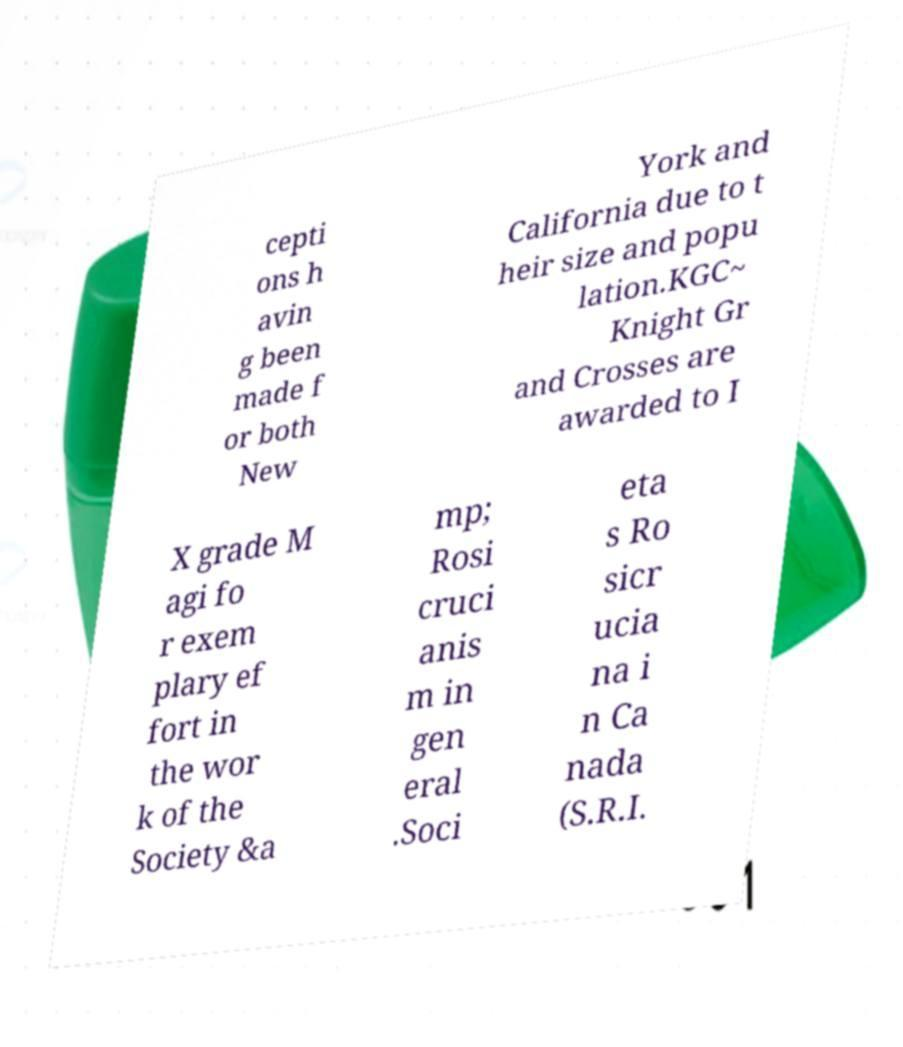Can you accurately transcribe the text from the provided image for me? cepti ons h avin g been made f or both New York and California due to t heir size and popu lation.KGC~ Knight Gr and Crosses are awarded to I X grade M agi fo r exem plary ef fort in the wor k of the Society &a mp; Rosi cruci anis m in gen eral .Soci eta s Ro sicr ucia na i n Ca nada (S.R.I. 